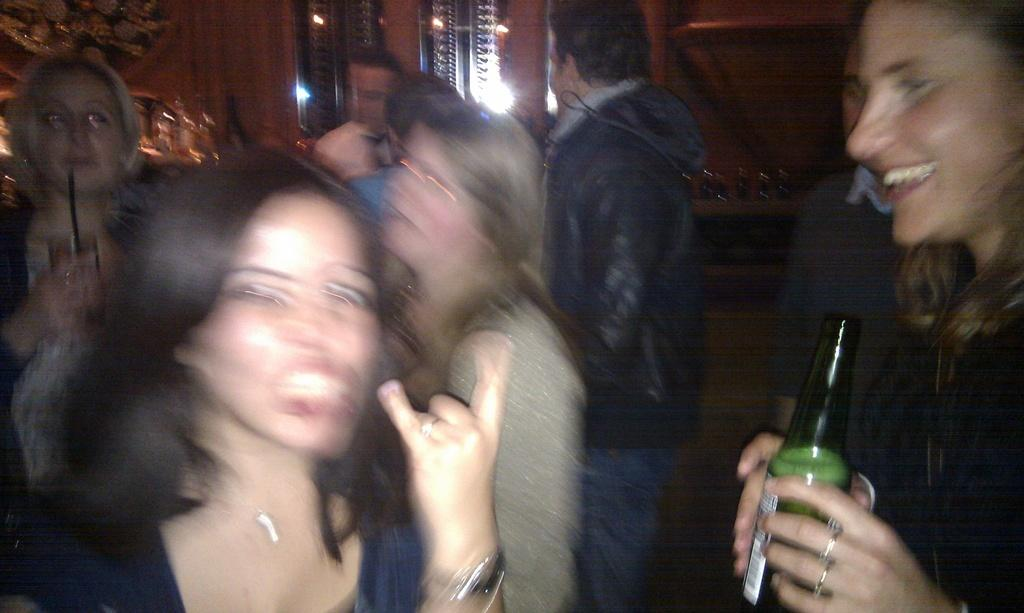What is the main subject of the image? The main subject of the image is a group of people. Can you describe the position of one of the individuals in the group? One woman is standing on the right side. What is the woman holding in her hand? The woman is holding a bottle. What type of knot is the woman tying in the image? There is no knot present in the image; the woman is holding a bottle. 